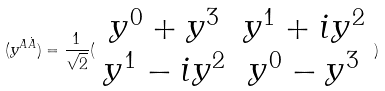Convert formula to latex. <formula><loc_0><loc_0><loc_500><loc_500>( y ^ { A \dot { A } } ) = \frac { 1 } { \sqrt { 2 } } ( \begin{array} { c c } y ^ { 0 } + y ^ { 3 } & y ^ { 1 } + i y ^ { 2 } \\ y ^ { 1 } - i y ^ { 2 } & y ^ { 0 } - y ^ { 3 } \end{array} )</formula> 